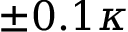Convert formula to latex. <formula><loc_0><loc_0><loc_500><loc_500>\pm 0 . 1 \kappa</formula> 